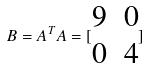Convert formula to latex. <formula><loc_0><loc_0><loc_500><loc_500>B = A ^ { T } A = [ \begin{matrix} 9 & 0 \\ 0 & 4 \end{matrix} ]</formula> 